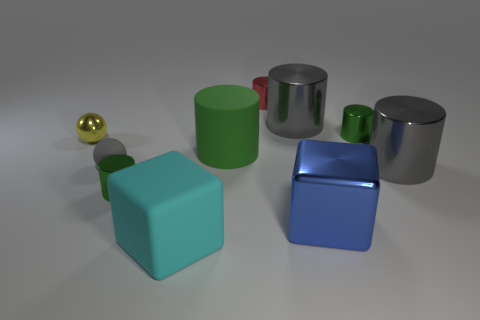What materials do the objects in the image seem to be made out of? The objects in the image have a variety of textures that suggest different materials. The spheres have shiny surfaces, indicating they might be made of polished metal or plastic. The cubes have a more matte finish, suggesting they could be made of a non-reflective material like rubber. The cylinders seem to have reflective sides and matte tops, which could imply a combination of materials with different finishes. 